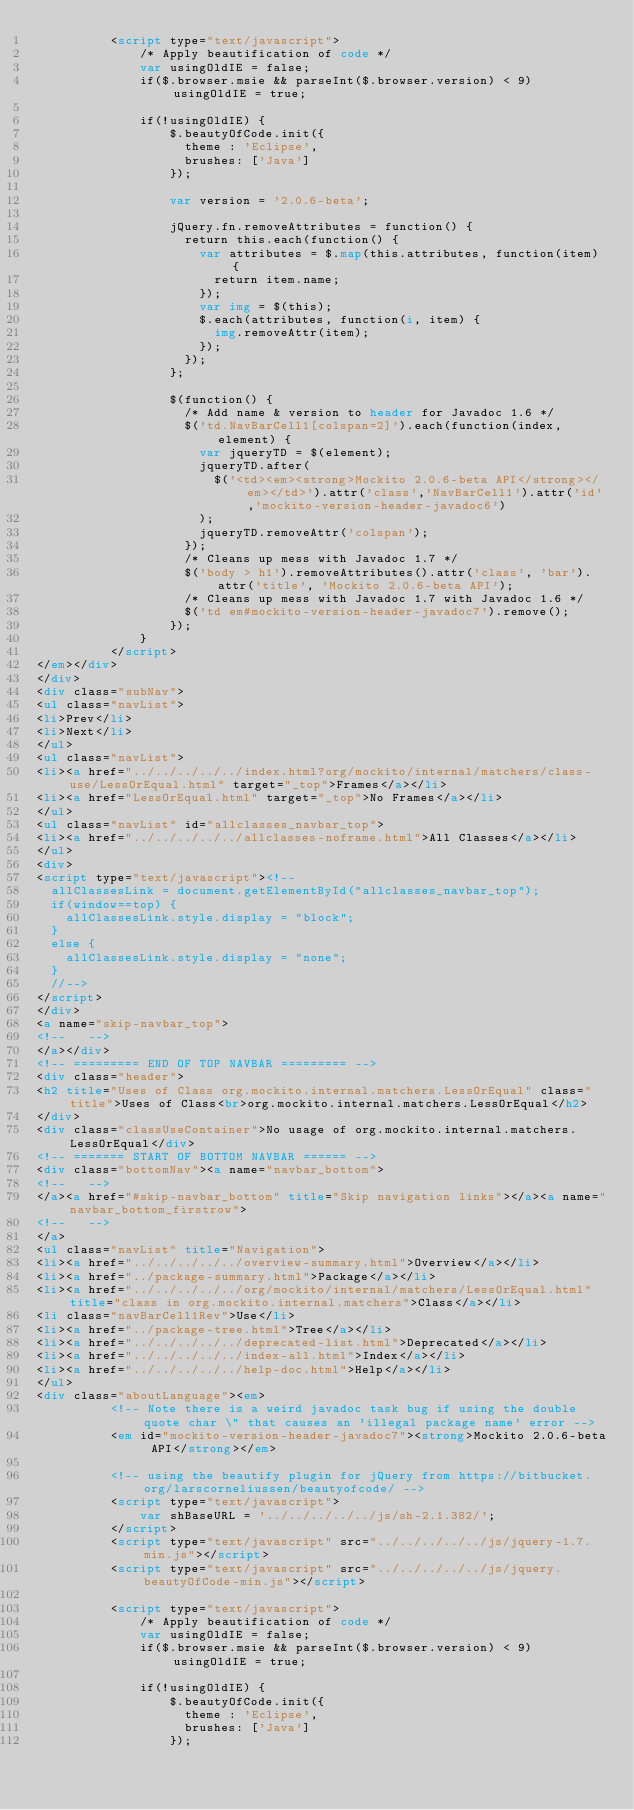<code> <loc_0><loc_0><loc_500><loc_500><_HTML_>          <script type="text/javascript">
              /* Apply beautification of code */
              var usingOldIE = false;
              if($.browser.msie && parseInt($.browser.version) < 9) usingOldIE = true;

              if(!usingOldIE) {
                  $.beautyOfCode.init({
                    theme : 'Eclipse',
                    brushes: ['Java']
                  });

                  var version = '2.0.6-beta';

                  jQuery.fn.removeAttributes = function() {
                    return this.each(function() {
                      var attributes = $.map(this.attributes, function(item) {
                        return item.name;
                      });
                      var img = $(this);
                      $.each(attributes, function(i, item) {
                        img.removeAttr(item);
                      });
                    });
                  };

                  $(function() {
                    /* Add name & version to header for Javadoc 1.6 */
                    $('td.NavBarCell1[colspan=2]').each(function(index, element) {
                      var jqueryTD = $(element);
                      jqueryTD.after(
                        $('<td><em><strong>Mockito 2.0.6-beta API</strong></em></td>').attr('class','NavBarCell1').attr('id','mockito-version-header-javadoc6')
                      );
                      jqueryTD.removeAttr('colspan');
                    });
                    /* Cleans up mess with Javadoc 1.7 */
                    $('body > h1').removeAttributes().attr('class', 'bar').attr('title', 'Mockito 2.0.6-beta API');
                    /* Cleans up mess with Javadoc 1.7 with Javadoc 1.6 */
                    $('td em#mockito-version-header-javadoc7').remove();
                  });
              }
          </script>
</em></div>
</div>
<div class="subNav">
<ul class="navList">
<li>Prev</li>
<li>Next</li>
</ul>
<ul class="navList">
<li><a href="../../../../../index.html?org/mockito/internal/matchers/class-use/LessOrEqual.html" target="_top">Frames</a></li>
<li><a href="LessOrEqual.html" target="_top">No Frames</a></li>
</ul>
<ul class="navList" id="allclasses_navbar_top">
<li><a href="../../../../../allclasses-noframe.html">All Classes</a></li>
</ul>
<div>
<script type="text/javascript"><!--
  allClassesLink = document.getElementById("allclasses_navbar_top");
  if(window==top) {
    allClassesLink.style.display = "block";
  }
  else {
    allClassesLink.style.display = "none";
  }
  //-->
</script>
</div>
<a name="skip-navbar_top">
<!--   -->
</a></div>
<!-- ========= END OF TOP NAVBAR ========= -->
<div class="header">
<h2 title="Uses of Class org.mockito.internal.matchers.LessOrEqual" class="title">Uses of Class<br>org.mockito.internal.matchers.LessOrEqual</h2>
</div>
<div class="classUseContainer">No usage of org.mockito.internal.matchers.LessOrEqual</div>
<!-- ======= START OF BOTTOM NAVBAR ====== -->
<div class="bottomNav"><a name="navbar_bottom">
<!--   -->
</a><a href="#skip-navbar_bottom" title="Skip navigation links"></a><a name="navbar_bottom_firstrow">
<!--   -->
</a>
<ul class="navList" title="Navigation">
<li><a href="../../../../../overview-summary.html">Overview</a></li>
<li><a href="../package-summary.html">Package</a></li>
<li><a href="../../../../../org/mockito/internal/matchers/LessOrEqual.html" title="class in org.mockito.internal.matchers">Class</a></li>
<li class="navBarCell1Rev">Use</li>
<li><a href="../package-tree.html">Tree</a></li>
<li><a href="../../../../../deprecated-list.html">Deprecated</a></li>
<li><a href="../../../../../index-all.html">Index</a></li>
<li><a href="../../../../../help-doc.html">Help</a></li>
</ul>
<div class="aboutLanguage"><em>
          <!-- Note there is a weird javadoc task bug if using the double quote char \" that causes an 'illegal package name' error -->
          <em id="mockito-version-header-javadoc7"><strong>Mockito 2.0.6-beta API</strong></em>

          <!-- using the beautify plugin for jQuery from https://bitbucket.org/larscorneliussen/beautyofcode/ -->
          <script type="text/javascript">
              var shBaseURL = '../../../../../js/sh-2.1.382/';
          </script>
          <script type="text/javascript" src="../../../../../js/jquery-1.7.min.js"></script>
          <script type="text/javascript" src="../../../../../js/jquery.beautyOfCode-min.js"></script>

          <script type="text/javascript">
              /* Apply beautification of code */
              var usingOldIE = false;
              if($.browser.msie && parseInt($.browser.version) < 9) usingOldIE = true;

              if(!usingOldIE) {
                  $.beautyOfCode.init({
                    theme : 'Eclipse',
                    brushes: ['Java']
                  });
</code> 